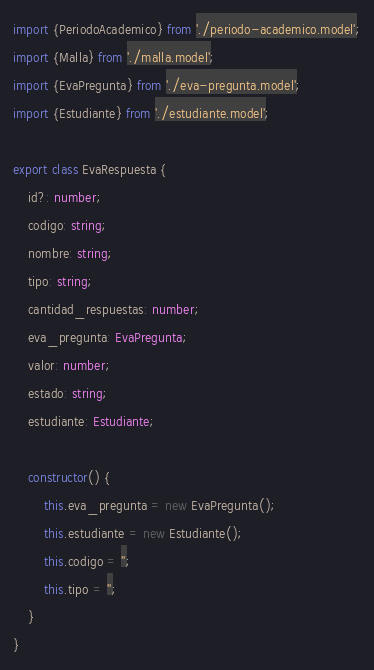<code> <loc_0><loc_0><loc_500><loc_500><_TypeScript_>import {PeriodoAcademico} from './periodo-academico.model';
import {Malla} from './malla.model';
import {EvaPregunta} from './eva-pregunta.model';
import {Estudiante} from './estudiante.model';

export class EvaRespuesta {
    id?: number;
    codigo: string;
    nombre: string;
    tipo: string;
    cantidad_respuestas: number;
    eva_pregunta: EvaPregunta;
    valor: number;
    estado: string;
    estudiante: Estudiante;

    constructor() {
        this.eva_pregunta = new EvaPregunta();
        this.estudiante = new Estudiante();
        this.codigo = '';
        this.tipo = '';
    }
}
</code> 